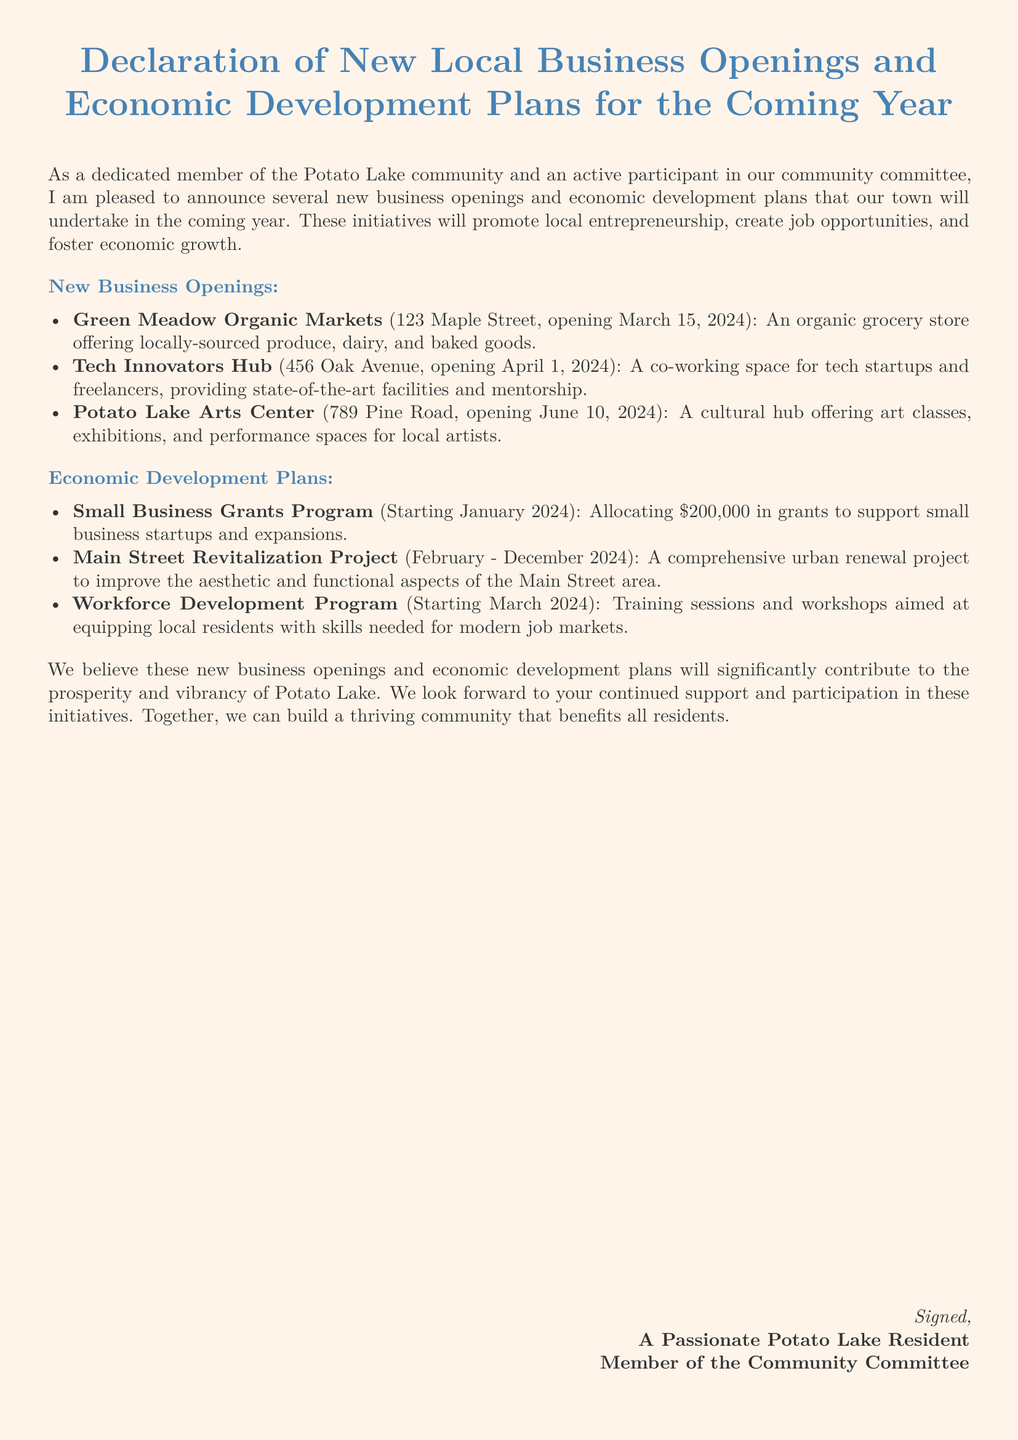What is the name of the first new business opening? The first new business is the one listed at the top of the new business openings section.
Answer: Green Meadow Organic Markets When is the opening date for the Tech Innovators Hub? The opening date for this business is mentioned right next to its name.
Answer: April 1, 2024 How much money is allocated for the Small Business Grants Program? The document states the specific amount allocated to this program.
Answer: $200,000 What project will occur between February and December 2024? This timeframe is associated with a specific economic development project mentioned in the document.
Answer: Main Street Revitalization Project What type of store is Green Meadow Organic Markets? This information can be found in the description of the business.
Answer: Organic grocery store What is the purpose of the Workforce Development Program? The program's aim is specified in the description of the economic development plans.
Answer: Training sessions and workshops How many businesses are announced to open in total? The total number can be determined by counting the listed new businesses.
Answer: Three Which new business will provide art classes? This business is identified in the new business openings section.
Answer: Potato Lake Arts Center 